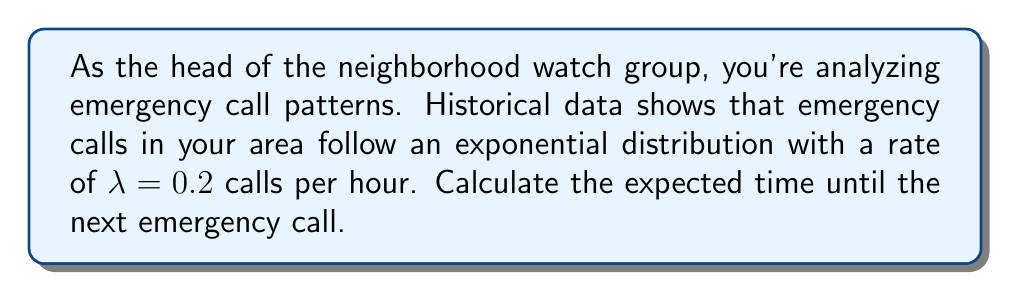Show me your answer to this math problem. To solve this problem, we'll follow these steps:

1. Recall that for an exponential distribution with rate $\lambda$, the expected value (mean) is given by:

   $E[X] = \frac{1}{\lambda}$

2. In this case, we're given that $\lambda = 0.2$ calls per hour.

3. Substitute this value into the formula:

   $E[X] = \frac{1}{0.2}$

4. Simplify:

   $E[X] = 5$

5. Interpret the result: The expected time until the next emergency call is 5 hours.

Note: The units of the result are the reciprocal of the units of $\lambda$. Since $\lambda$ is given in calls per hour, the result is in hours.
Answer: 5 hours 